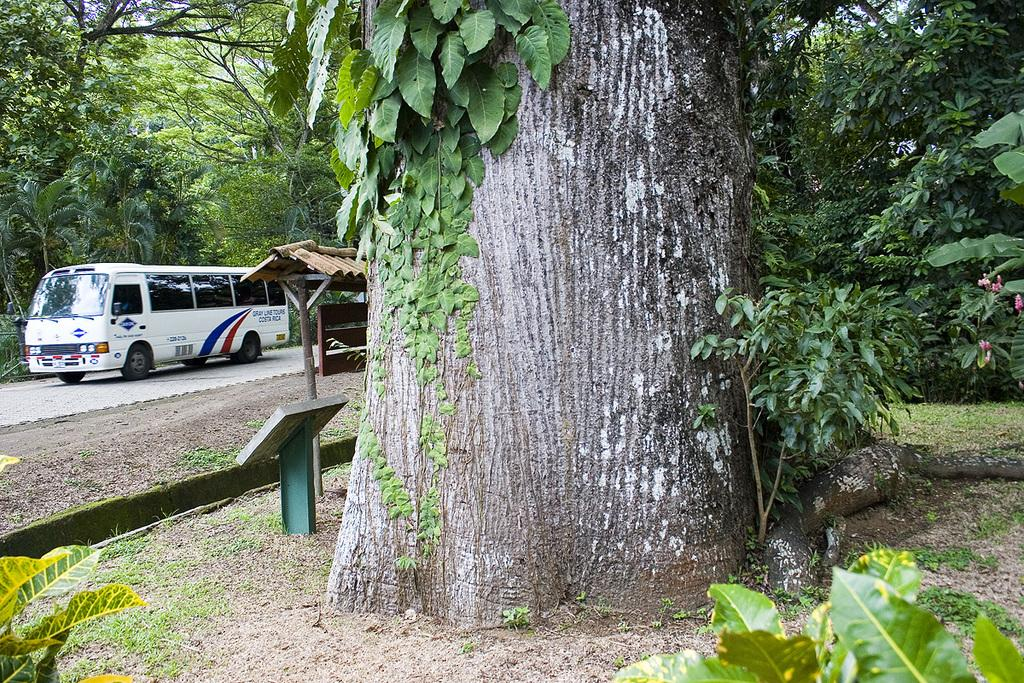What is the main subject of the image? There is a bus on the road in the image. What can be seen in the background of the image? There are trees, a shed, boards, and plants in the background of the image. What type of fruit is hanging from the trees in the image? There is no fruit visible in the image; only trees, a shed, boards, and plants can be seen in the background. What songs are being played by the bus in the image? The image does not provide any information about songs being played; it only shows a bus on the road and various elements in the background. 